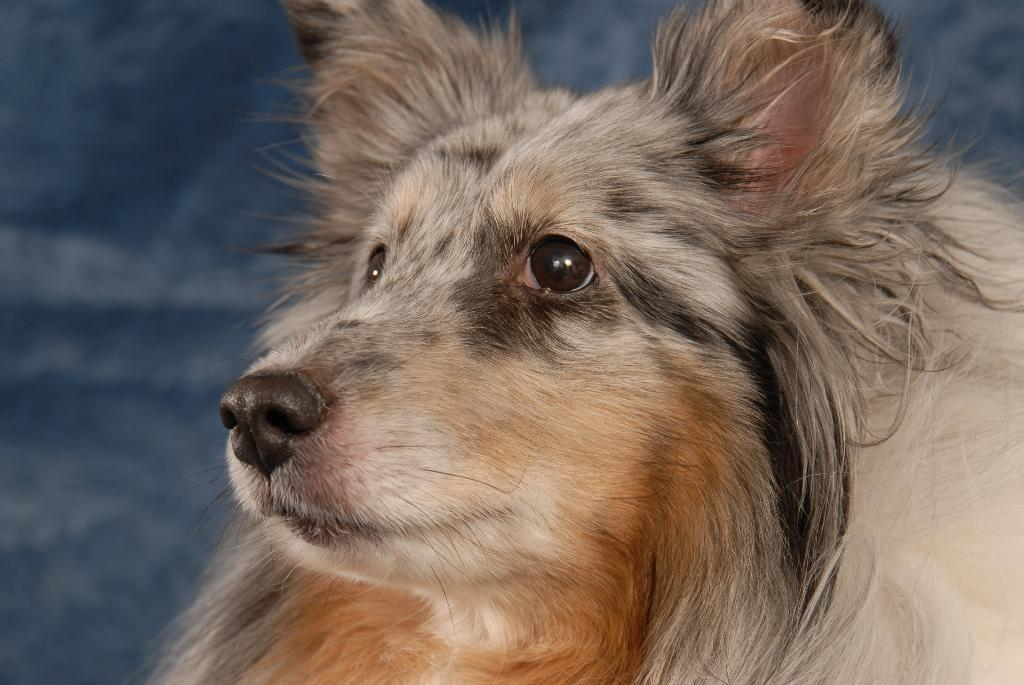What type of animal is in the image? The animal in the image has a black, brown, and white color combination. Can you describe the color combination of the animal? The animal has a black, brown, and white color combination. What can be seen in the background of the image? There are objects in the background of the image. Is the animal asking a question in the image? There is no indication in the image that the animal is asking a question, as animals do not have the ability to ask questions. 